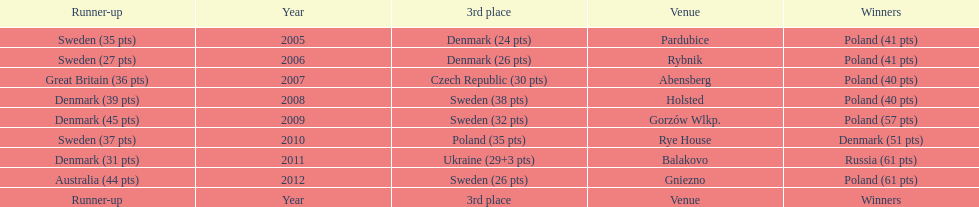What is the total number of points earned in the years 2009? 134. 